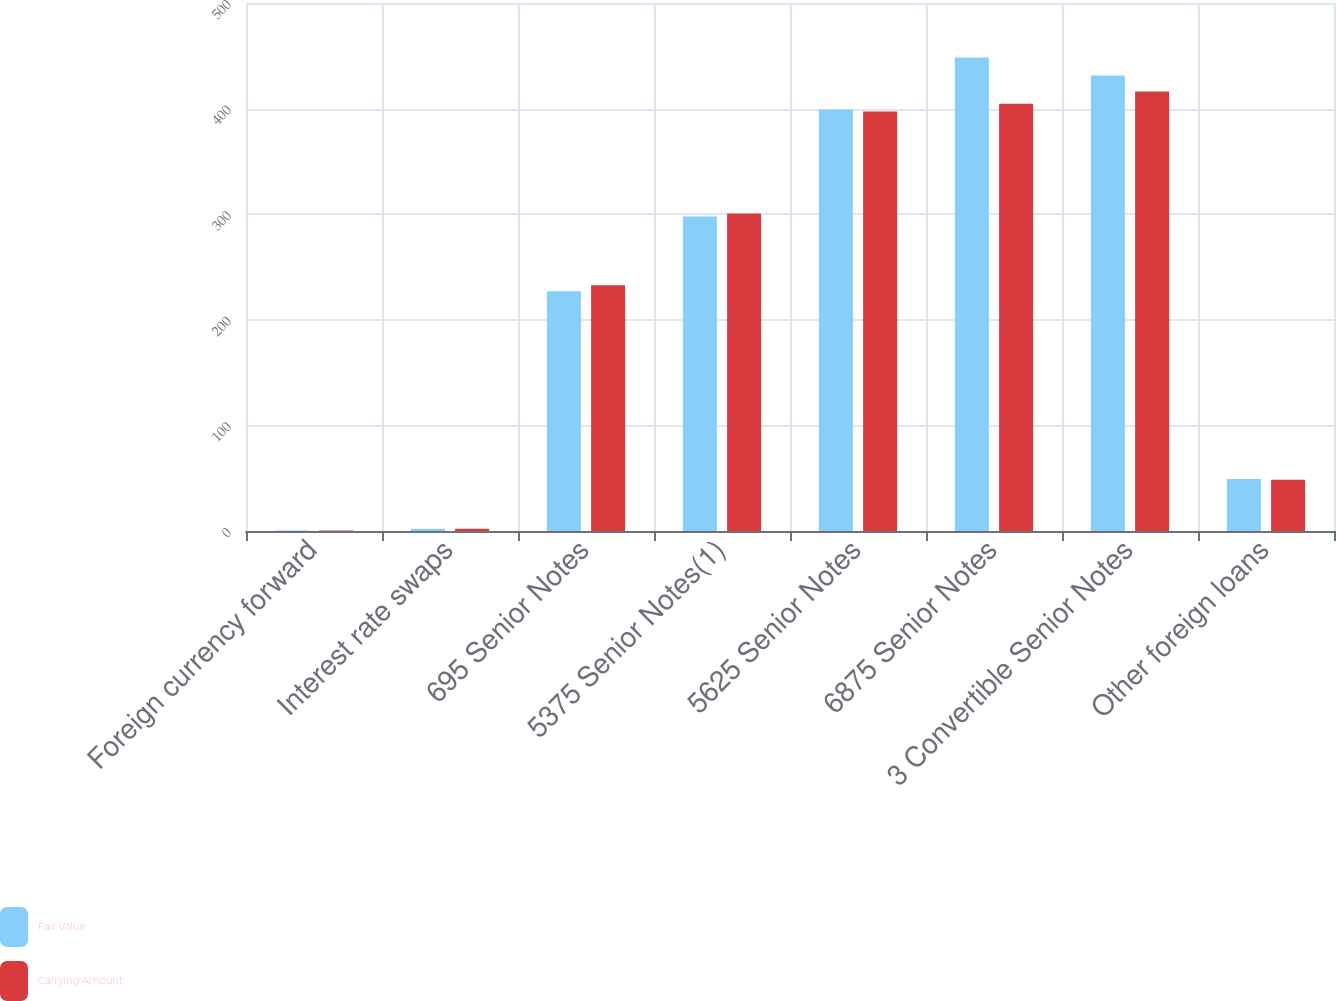<chart> <loc_0><loc_0><loc_500><loc_500><stacked_bar_chart><ecel><fcel>Foreign currency forward<fcel>Interest rate swaps<fcel>695 Senior Notes<fcel>5375 Senior Notes(1)<fcel>5625 Senior Notes<fcel>6875 Senior Notes<fcel>3 Convertible Senior Notes<fcel>Other foreign loans<nl><fcel>Fair Value<fcel>0.5<fcel>2.1<fcel>227<fcel>297.8<fcel>399.2<fcel>448.5<fcel>431.3<fcel>49.2<nl><fcel>Carrying Amount<fcel>0.5<fcel>2.1<fcel>232.7<fcel>300.6<fcel>397.2<fcel>404.6<fcel>416.1<fcel>48.5<nl></chart> 